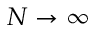Convert formula to latex. <formula><loc_0><loc_0><loc_500><loc_500>N \rightarrow \infty</formula> 